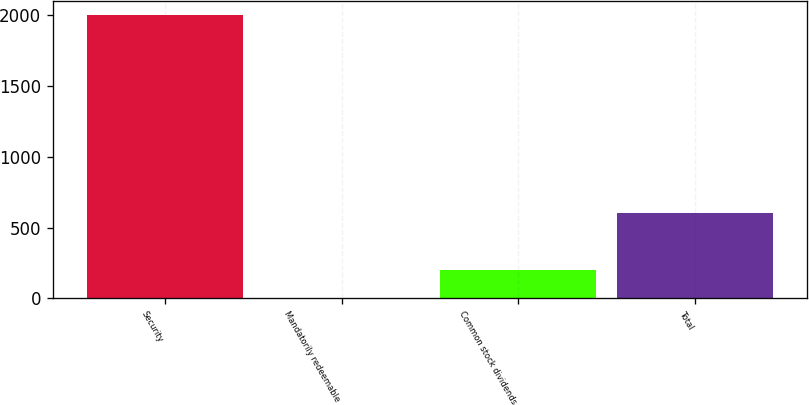Convert chart to OTSL. <chart><loc_0><loc_0><loc_500><loc_500><bar_chart><fcel>Security<fcel>Mandatorily redeemable<fcel>Common stock dividends<fcel>Total<nl><fcel>2004<fcel>1<fcel>201.3<fcel>601.9<nl></chart> 